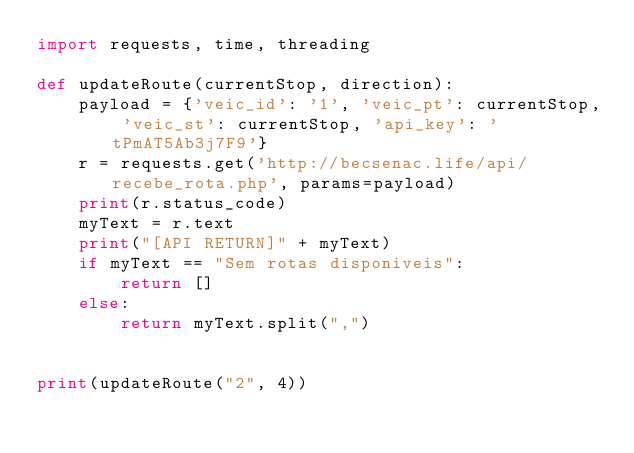<code> <loc_0><loc_0><loc_500><loc_500><_Python_>import requests, time, threading

def updateRoute(currentStop, direction):
    payload = {'veic_id': '1', 'veic_pt': currentStop, 'veic_st': currentStop, 'api_key': 'tPmAT5Ab3j7F9'}
    r = requests.get('http://becsenac.life/api/recebe_rota.php', params=payload)
    print(r.status_code)
    myText = r.text
    print("[API RETURN]" + myText)
    if myText == "Sem rotas disponiveis":
        return []
    else:
        return myText.split(",")
    

print(updateRoute("2", 4))</code> 